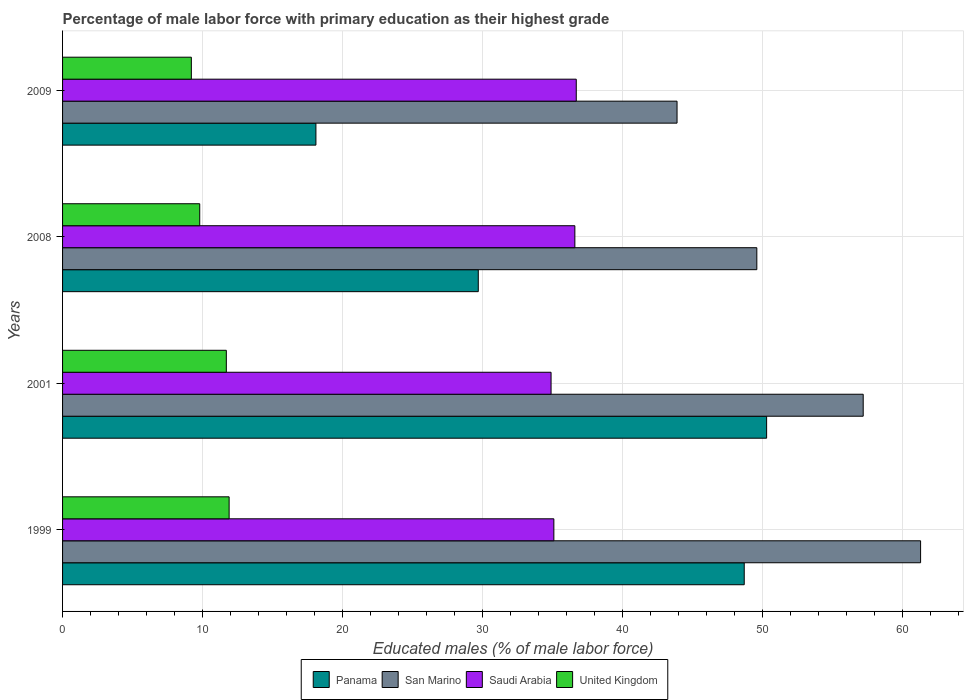How many different coloured bars are there?
Your response must be concise. 4. How many groups of bars are there?
Offer a very short reply. 4. Are the number of bars per tick equal to the number of legend labels?
Your answer should be compact. Yes. How many bars are there on the 2nd tick from the bottom?
Ensure brevity in your answer.  4. What is the percentage of male labor force with primary education in San Marino in 2001?
Keep it short and to the point. 57.2. Across all years, what is the maximum percentage of male labor force with primary education in United Kingdom?
Offer a very short reply. 11.9. Across all years, what is the minimum percentage of male labor force with primary education in Panama?
Your response must be concise. 18.1. What is the total percentage of male labor force with primary education in Panama in the graph?
Ensure brevity in your answer.  146.8. What is the difference between the percentage of male labor force with primary education in San Marino in 2008 and that in 2009?
Make the answer very short. 5.7. What is the difference between the percentage of male labor force with primary education in United Kingdom in 2001 and the percentage of male labor force with primary education in San Marino in 1999?
Your answer should be very brief. -49.6. What is the average percentage of male labor force with primary education in United Kingdom per year?
Offer a very short reply. 10.65. In the year 1999, what is the difference between the percentage of male labor force with primary education in Panama and percentage of male labor force with primary education in Saudi Arabia?
Keep it short and to the point. 13.6. What is the ratio of the percentage of male labor force with primary education in Panama in 2008 to that in 2009?
Give a very brief answer. 1.64. Is the percentage of male labor force with primary education in Saudi Arabia in 1999 less than that in 2008?
Keep it short and to the point. Yes. Is the difference between the percentage of male labor force with primary education in Panama in 1999 and 2009 greater than the difference between the percentage of male labor force with primary education in Saudi Arabia in 1999 and 2009?
Offer a terse response. Yes. What is the difference between the highest and the second highest percentage of male labor force with primary education in San Marino?
Ensure brevity in your answer.  4.1. What is the difference between the highest and the lowest percentage of male labor force with primary education in United Kingdom?
Give a very brief answer. 2.7. In how many years, is the percentage of male labor force with primary education in United Kingdom greater than the average percentage of male labor force with primary education in United Kingdom taken over all years?
Your response must be concise. 2. Is it the case that in every year, the sum of the percentage of male labor force with primary education in Saudi Arabia and percentage of male labor force with primary education in United Kingdom is greater than the sum of percentage of male labor force with primary education in San Marino and percentage of male labor force with primary education in Panama?
Offer a very short reply. No. What does the 3rd bar from the top in 1999 represents?
Your answer should be compact. San Marino. What does the 1st bar from the bottom in 2008 represents?
Your answer should be very brief. Panama. Is it the case that in every year, the sum of the percentage of male labor force with primary education in Panama and percentage of male labor force with primary education in San Marino is greater than the percentage of male labor force with primary education in United Kingdom?
Give a very brief answer. Yes. Does the graph contain any zero values?
Offer a terse response. No. Does the graph contain grids?
Provide a succinct answer. Yes. Where does the legend appear in the graph?
Provide a succinct answer. Bottom center. How are the legend labels stacked?
Give a very brief answer. Horizontal. What is the title of the graph?
Provide a short and direct response. Percentage of male labor force with primary education as their highest grade. Does "Latvia" appear as one of the legend labels in the graph?
Your answer should be compact. No. What is the label or title of the X-axis?
Your answer should be very brief. Educated males (% of male labor force). What is the Educated males (% of male labor force) of Panama in 1999?
Your answer should be very brief. 48.7. What is the Educated males (% of male labor force) in San Marino in 1999?
Offer a very short reply. 61.3. What is the Educated males (% of male labor force) in Saudi Arabia in 1999?
Your answer should be compact. 35.1. What is the Educated males (% of male labor force) in United Kingdom in 1999?
Your answer should be very brief. 11.9. What is the Educated males (% of male labor force) in Panama in 2001?
Provide a short and direct response. 50.3. What is the Educated males (% of male labor force) of San Marino in 2001?
Provide a succinct answer. 57.2. What is the Educated males (% of male labor force) of Saudi Arabia in 2001?
Offer a very short reply. 34.9. What is the Educated males (% of male labor force) in United Kingdom in 2001?
Ensure brevity in your answer.  11.7. What is the Educated males (% of male labor force) in Panama in 2008?
Provide a short and direct response. 29.7. What is the Educated males (% of male labor force) of San Marino in 2008?
Your answer should be compact. 49.6. What is the Educated males (% of male labor force) of Saudi Arabia in 2008?
Provide a succinct answer. 36.6. What is the Educated males (% of male labor force) of United Kingdom in 2008?
Provide a succinct answer. 9.8. What is the Educated males (% of male labor force) of Panama in 2009?
Make the answer very short. 18.1. What is the Educated males (% of male labor force) of San Marino in 2009?
Provide a succinct answer. 43.9. What is the Educated males (% of male labor force) of Saudi Arabia in 2009?
Your response must be concise. 36.7. What is the Educated males (% of male labor force) in United Kingdom in 2009?
Offer a terse response. 9.2. Across all years, what is the maximum Educated males (% of male labor force) in Panama?
Your answer should be very brief. 50.3. Across all years, what is the maximum Educated males (% of male labor force) in San Marino?
Ensure brevity in your answer.  61.3. Across all years, what is the maximum Educated males (% of male labor force) of Saudi Arabia?
Ensure brevity in your answer.  36.7. Across all years, what is the maximum Educated males (% of male labor force) in United Kingdom?
Give a very brief answer. 11.9. Across all years, what is the minimum Educated males (% of male labor force) in Panama?
Offer a terse response. 18.1. Across all years, what is the minimum Educated males (% of male labor force) of San Marino?
Provide a short and direct response. 43.9. Across all years, what is the minimum Educated males (% of male labor force) in Saudi Arabia?
Your answer should be very brief. 34.9. Across all years, what is the minimum Educated males (% of male labor force) in United Kingdom?
Your answer should be compact. 9.2. What is the total Educated males (% of male labor force) of Panama in the graph?
Ensure brevity in your answer.  146.8. What is the total Educated males (% of male labor force) in San Marino in the graph?
Keep it short and to the point. 212. What is the total Educated males (% of male labor force) of Saudi Arabia in the graph?
Offer a terse response. 143.3. What is the total Educated males (% of male labor force) in United Kingdom in the graph?
Your response must be concise. 42.6. What is the difference between the Educated males (% of male labor force) of Panama in 1999 and that in 2001?
Ensure brevity in your answer.  -1.6. What is the difference between the Educated males (% of male labor force) of United Kingdom in 1999 and that in 2001?
Ensure brevity in your answer.  0.2. What is the difference between the Educated males (% of male labor force) of San Marino in 1999 and that in 2008?
Give a very brief answer. 11.7. What is the difference between the Educated males (% of male labor force) in United Kingdom in 1999 and that in 2008?
Keep it short and to the point. 2.1. What is the difference between the Educated males (% of male labor force) in Panama in 1999 and that in 2009?
Your answer should be compact. 30.6. What is the difference between the Educated males (% of male labor force) in San Marino in 1999 and that in 2009?
Your answer should be very brief. 17.4. What is the difference between the Educated males (% of male labor force) of Panama in 2001 and that in 2008?
Provide a short and direct response. 20.6. What is the difference between the Educated males (% of male labor force) in San Marino in 2001 and that in 2008?
Offer a very short reply. 7.6. What is the difference between the Educated males (% of male labor force) in United Kingdom in 2001 and that in 2008?
Your answer should be compact. 1.9. What is the difference between the Educated males (% of male labor force) of Panama in 2001 and that in 2009?
Your answer should be very brief. 32.2. What is the difference between the Educated males (% of male labor force) of Saudi Arabia in 2001 and that in 2009?
Your answer should be very brief. -1.8. What is the difference between the Educated males (% of male labor force) in Saudi Arabia in 2008 and that in 2009?
Keep it short and to the point. -0.1. What is the difference between the Educated males (% of male labor force) in Panama in 1999 and the Educated males (% of male labor force) in San Marino in 2001?
Your answer should be very brief. -8.5. What is the difference between the Educated males (% of male labor force) in Panama in 1999 and the Educated males (% of male labor force) in Saudi Arabia in 2001?
Give a very brief answer. 13.8. What is the difference between the Educated males (% of male labor force) of Panama in 1999 and the Educated males (% of male labor force) of United Kingdom in 2001?
Your answer should be very brief. 37. What is the difference between the Educated males (% of male labor force) of San Marino in 1999 and the Educated males (% of male labor force) of Saudi Arabia in 2001?
Ensure brevity in your answer.  26.4. What is the difference between the Educated males (% of male labor force) of San Marino in 1999 and the Educated males (% of male labor force) of United Kingdom in 2001?
Keep it short and to the point. 49.6. What is the difference between the Educated males (% of male labor force) of Saudi Arabia in 1999 and the Educated males (% of male labor force) of United Kingdom in 2001?
Offer a terse response. 23.4. What is the difference between the Educated males (% of male labor force) in Panama in 1999 and the Educated males (% of male labor force) in United Kingdom in 2008?
Your answer should be very brief. 38.9. What is the difference between the Educated males (% of male labor force) in San Marino in 1999 and the Educated males (% of male labor force) in Saudi Arabia in 2008?
Provide a succinct answer. 24.7. What is the difference between the Educated males (% of male labor force) of San Marino in 1999 and the Educated males (% of male labor force) of United Kingdom in 2008?
Provide a succinct answer. 51.5. What is the difference between the Educated males (% of male labor force) in Saudi Arabia in 1999 and the Educated males (% of male labor force) in United Kingdom in 2008?
Your answer should be very brief. 25.3. What is the difference between the Educated males (% of male labor force) in Panama in 1999 and the Educated males (% of male labor force) in United Kingdom in 2009?
Offer a very short reply. 39.5. What is the difference between the Educated males (% of male labor force) of San Marino in 1999 and the Educated males (% of male labor force) of Saudi Arabia in 2009?
Give a very brief answer. 24.6. What is the difference between the Educated males (% of male labor force) of San Marino in 1999 and the Educated males (% of male labor force) of United Kingdom in 2009?
Provide a succinct answer. 52.1. What is the difference between the Educated males (% of male labor force) of Saudi Arabia in 1999 and the Educated males (% of male labor force) of United Kingdom in 2009?
Provide a short and direct response. 25.9. What is the difference between the Educated males (% of male labor force) in Panama in 2001 and the Educated males (% of male labor force) in San Marino in 2008?
Keep it short and to the point. 0.7. What is the difference between the Educated males (% of male labor force) of Panama in 2001 and the Educated males (% of male labor force) of United Kingdom in 2008?
Provide a succinct answer. 40.5. What is the difference between the Educated males (% of male labor force) in San Marino in 2001 and the Educated males (% of male labor force) in Saudi Arabia in 2008?
Offer a terse response. 20.6. What is the difference between the Educated males (% of male labor force) of San Marino in 2001 and the Educated males (% of male labor force) of United Kingdom in 2008?
Keep it short and to the point. 47.4. What is the difference between the Educated males (% of male labor force) of Saudi Arabia in 2001 and the Educated males (% of male labor force) of United Kingdom in 2008?
Give a very brief answer. 25.1. What is the difference between the Educated males (% of male labor force) in Panama in 2001 and the Educated males (% of male labor force) in San Marino in 2009?
Offer a very short reply. 6.4. What is the difference between the Educated males (% of male labor force) in Panama in 2001 and the Educated males (% of male labor force) in Saudi Arabia in 2009?
Ensure brevity in your answer.  13.6. What is the difference between the Educated males (% of male labor force) in Panama in 2001 and the Educated males (% of male labor force) in United Kingdom in 2009?
Offer a terse response. 41.1. What is the difference between the Educated males (% of male labor force) in Saudi Arabia in 2001 and the Educated males (% of male labor force) in United Kingdom in 2009?
Your answer should be compact. 25.7. What is the difference between the Educated males (% of male labor force) in Panama in 2008 and the Educated males (% of male labor force) in San Marino in 2009?
Make the answer very short. -14.2. What is the difference between the Educated males (% of male labor force) in Panama in 2008 and the Educated males (% of male labor force) in Saudi Arabia in 2009?
Your response must be concise. -7. What is the difference between the Educated males (% of male labor force) in Panama in 2008 and the Educated males (% of male labor force) in United Kingdom in 2009?
Your answer should be very brief. 20.5. What is the difference between the Educated males (% of male labor force) of San Marino in 2008 and the Educated males (% of male labor force) of United Kingdom in 2009?
Give a very brief answer. 40.4. What is the difference between the Educated males (% of male labor force) of Saudi Arabia in 2008 and the Educated males (% of male labor force) of United Kingdom in 2009?
Offer a very short reply. 27.4. What is the average Educated males (% of male labor force) in Panama per year?
Make the answer very short. 36.7. What is the average Educated males (% of male labor force) of Saudi Arabia per year?
Provide a succinct answer. 35.83. What is the average Educated males (% of male labor force) in United Kingdom per year?
Ensure brevity in your answer.  10.65. In the year 1999, what is the difference between the Educated males (% of male labor force) of Panama and Educated males (% of male labor force) of Saudi Arabia?
Your answer should be very brief. 13.6. In the year 1999, what is the difference between the Educated males (% of male labor force) in Panama and Educated males (% of male labor force) in United Kingdom?
Provide a short and direct response. 36.8. In the year 1999, what is the difference between the Educated males (% of male labor force) in San Marino and Educated males (% of male labor force) in Saudi Arabia?
Your answer should be very brief. 26.2. In the year 1999, what is the difference between the Educated males (% of male labor force) in San Marino and Educated males (% of male labor force) in United Kingdom?
Provide a succinct answer. 49.4. In the year 1999, what is the difference between the Educated males (% of male labor force) in Saudi Arabia and Educated males (% of male labor force) in United Kingdom?
Ensure brevity in your answer.  23.2. In the year 2001, what is the difference between the Educated males (% of male labor force) in Panama and Educated males (% of male labor force) in San Marino?
Offer a very short reply. -6.9. In the year 2001, what is the difference between the Educated males (% of male labor force) in Panama and Educated males (% of male labor force) in Saudi Arabia?
Give a very brief answer. 15.4. In the year 2001, what is the difference between the Educated males (% of male labor force) in Panama and Educated males (% of male labor force) in United Kingdom?
Provide a succinct answer. 38.6. In the year 2001, what is the difference between the Educated males (% of male labor force) in San Marino and Educated males (% of male labor force) in Saudi Arabia?
Offer a very short reply. 22.3. In the year 2001, what is the difference between the Educated males (% of male labor force) in San Marino and Educated males (% of male labor force) in United Kingdom?
Provide a succinct answer. 45.5. In the year 2001, what is the difference between the Educated males (% of male labor force) in Saudi Arabia and Educated males (% of male labor force) in United Kingdom?
Provide a succinct answer. 23.2. In the year 2008, what is the difference between the Educated males (% of male labor force) of Panama and Educated males (% of male labor force) of San Marino?
Your answer should be very brief. -19.9. In the year 2008, what is the difference between the Educated males (% of male labor force) in Panama and Educated males (% of male labor force) in Saudi Arabia?
Your answer should be very brief. -6.9. In the year 2008, what is the difference between the Educated males (% of male labor force) in San Marino and Educated males (% of male labor force) in Saudi Arabia?
Your answer should be very brief. 13. In the year 2008, what is the difference between the Educated males (% of male labor force) in San Marino and Educated males (% of male labor force) in United Kingdom?
Ensure brevity in your answer.  39.8. In the year 2008, what is the difference between the Educated males (% of male labor force) in Saudi Arabia and Educated males (% of male labor force) in United Kingdom?
Make the answer very short. 26.8. In the year 2009, what is the difference between the Educated males (% of male labor force) in Panama and Educated males (% of male labor force) in San Marino?
Keep it short and to the point. -25.8. In the year 2009, what is the difference between the Educated males (% of male labor force) in Panama and Educated males (% of male labor force) in Saudi Arabia?
Your response must be concise. -18.6. In the year 2009, what is the difference between the Educated males (% of male labor force) of Panama and Educated males (% of male labor force) of United Kingdom?
Offer a terse response. 8.9. In the year 2009, what is the difference between the Educated males (% of male labor force) in San Marino and Educated males (% of male labor force) in Saudi Arabia?
Offer a terse response. 7.2. In the year 2009, what is the difference between the Educated males (% of male labor force) of San Marino and Educated males (% of male labor force) of United Kingdom?
Your response must be concise. 34.7. What is the ratio of the Educated males (% of male labor force) in Panama in 1999 to that in 2001?
Your response must be concise. 0.97. What is the ratio of the Educated males (% of male labor force) of San Marino in 1999 to that in 2001?
Keep it short and to the point. 1.07. What is the ratio of the Educated males (% of male labor force) in Saudi Arabia in 1999 to that in 2001?
Offer a very short reply. 1.01. What is the ratio of the Educated males (% of male labor force) of United Kingdom in 1999 to that in 2001?
Keep it short and to the point. 1.02. What is the ratio of the Educated males (% of male labor force) in Panama in 1999 to that in 2008?
Give a very brief answer. 1.64. What is the ratio of the Educated males (% of male labor force) of San Marino in 1999 to that in 2008?
Ensure brevity in your answer.  1.24. What is the ratio of the Educated males (% of male labor force) of United Kingdom in 1999 to that in 2008?
Your answer should be compact. 1.21. What is the ratio of the Educated males (% of male labor force) of Panama in 1999 to that in 2009?
Your answer should be compact. 2.69. What is the ratio of the Educated males (% of male labor force) of San Marino in 1999 to that in 2009?
Keep it short and to the point. 1.4. What is the ratio of the Educated males (% of male labor force) in Saudi Arabia in 1999 to that in 2009?
Your response must be concise. 0.96. What is the ratio of the Educated males (% of male labor force) in United Kingdom in 1999 to that in 2009?
Keep it short and to the point. 1.29. What is the ratio of the Educated males (% of male labor force) of Panama in 2001 to that in 2008?
Provide a succinct answer. 1.69. What is the ratio of the Educated males (% of male labor force) of San Marino in 2001 to that in 2008?
Give a very brief answer. 1.15. What is the ratio of the Educated males (% of male labor force) of Saudi Arabia in 2001 to that in 2008?
Your answer should be very brief. 0.95. What is the ratio of the Educated males (% of male labor force) of United Kingdom in 2001 to that in 2008?
Give a very brief answer. 1.19. What is the ratio of the Educated males (% of male labor force) in Panama in 2001 to that in 2009?
Offer a very short reply. 2.78. What is the ratio of the Educated males (% of male labor force) in San Marino in 2001 to that in 2009?
Your answer should be compact. 1.3. What is the ratio of the Educated males (% of male labor force) in Saudi Arabia in 2001 to that in 2009?
Your answer should be compact. 0.95. What is the ratio of the Educated males (% of male labor force) in United Kingdom in 2001 to that in 2009?
Your answer should be very brief. 1.27. What is the ratio of the Educated males (% of male labor force) in Panama in 2008 to that in 2009?
Keep it short and to the point. 1.64. What is the ratio of the Educated males (% of male labor force) of San Marino in 2008 to that in 2009?
Keep it short and to the point. 1.13. What is the ratio of the Educated males (% of male labor force) of United Kingdom in 2008 to that in 2009?
Your response must be concise. 1.07. What is the difference between the highest and the second highest Educated males (% of male labor force) of Panama?
Provide a short and direct response. 1.6. What is the difference between the highest and the second highest Educated males (% of male labor force) in San Marino?
Keep it short and to the point. 4.1. What is the difference between the highest and the second highest Educated males (% of male labor force) of United Kingdom?
Give a very brief answer. 0.2. What is the difference between the highest and the lowest Educated males (% of male labor force) in Panama?
Your answer should be compact. 32.2. What is the difference between the highest and the lowest Educated males (% of male labor force) of San Marino?
Your answer should be very brief. 17.4. 